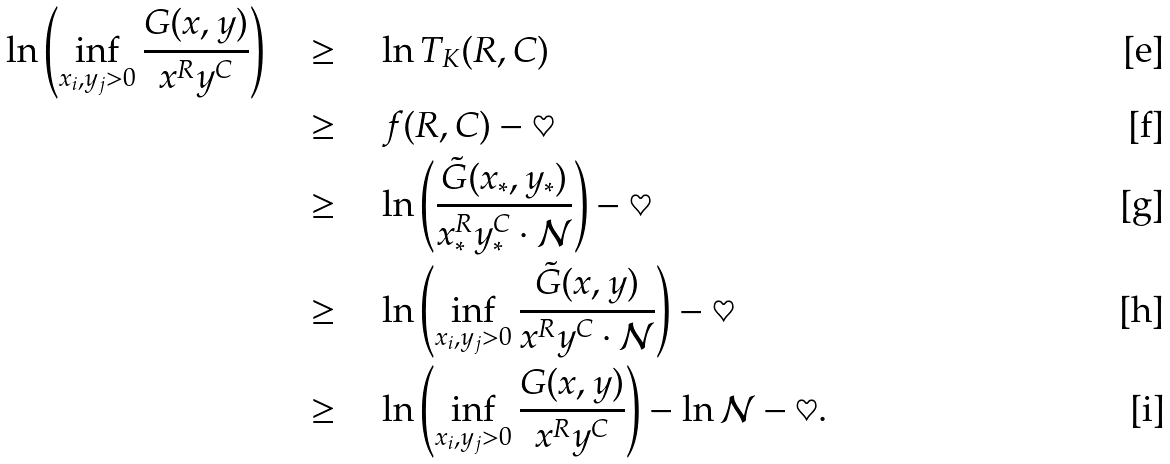<formula> <loc_0><loc_0><loc_500><loc_500>\ln \left ( \inf _ { x _ { i } , y _ { j } > 0 } \frac { G ( { x } , { y } ) } { { x } ^ { R } { y } ^ { C } } \right ) \quad & \geq \quad \ln T _ { K } ( R , C ) \\ & \geq \quad f ( R , C ) - \heartsuit \\ & \geq \quad \ln \left ( \frac { \tilde { G } ( { x } _ { * } , { y } _ { * } ) } { { x } _ { * } ^ { R } { y } _ { * } ^ { C } \cdot { \mathcal { N } } } \right ) - \heartsuit \\ & \geq \quad \ln \left ( \inf _ { x _ { i } , y _ { j } > 0 } \frac { \tilde { G } ( { x } , { y } ) } { { x } ^ { R } { y } ^ { C } \cdot { \mathcal { N } } } \right ) - \heartsuit \\ & \geq \quad \ln \left ( \inf _ { x _ { i } , y _ { j } > 0 } \frac { G ( { x } , { y } ) } { { x } ^ { R } { y } ^ { C } } \right ) - \ln { \mathcal { N } } - \heartsuit .</formula> 